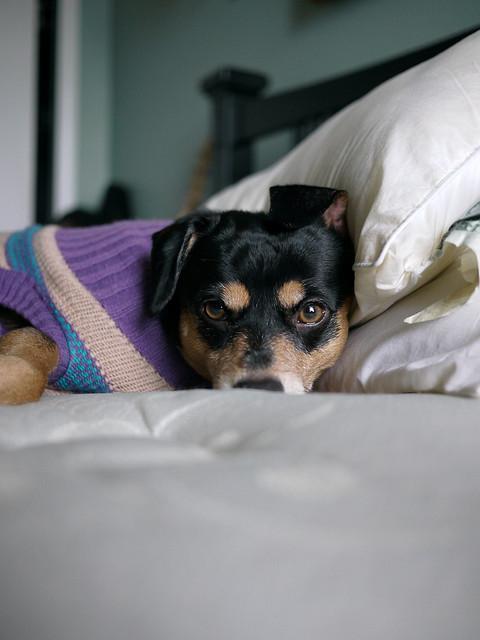How many beds can you see?
Give a very brief answer. 1. How many sheep are there?
Give a very brief answer. 0. 